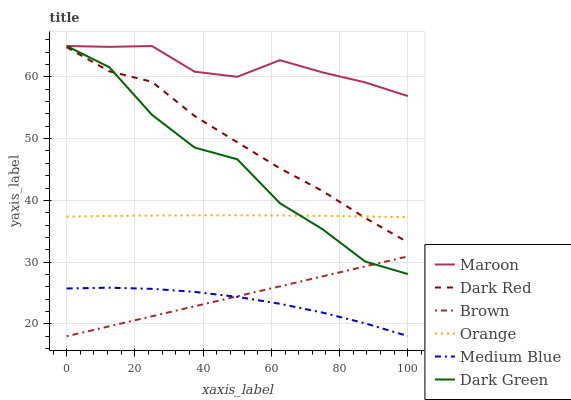Does Medium Blue have the minimum area under the curve?
Answer yes or no. Yes. Does Maroon have the maximum area under the curve?
Answer yes or no. Yes. Does Dark Red have the minimum area under the curve?
Answer yes or no. No. Does Dark Red have the maximum area under the curve?
Answer yes or no. No. Is Brown the smoothest?
Answer yes or no. Yes. Is Dark Green the roughest?
Answer yes or no. Yes. Is Dark Red the smoothest?
Answer yes or no. No. Is Dark Red the roughest?
Answer yes or no. No. Does Brown have the lowest value?
Answer yes or no. Yes. Does Dark Red have the lowest value?
Answer yes or no. No. Does Dark Green have the highest value?
Answer yes or no. Yes. Does Dark Red have the highest value?
Answer yes or no. No. Is Brown less than Maroon?
Answer yes or no. Yes. Is Maroon greater than Dark Red?
Answer yes or no. Yes. Does Maroon intersect Dark Green?
Answer yes or no. Yes. Is Maroon less than Dark Green?
Answer yes or no. No. Is Maroon greater than Dark Green?
Answer yes or no. No. Does Brown intersect Maroon?
Answer yes or no. No. 